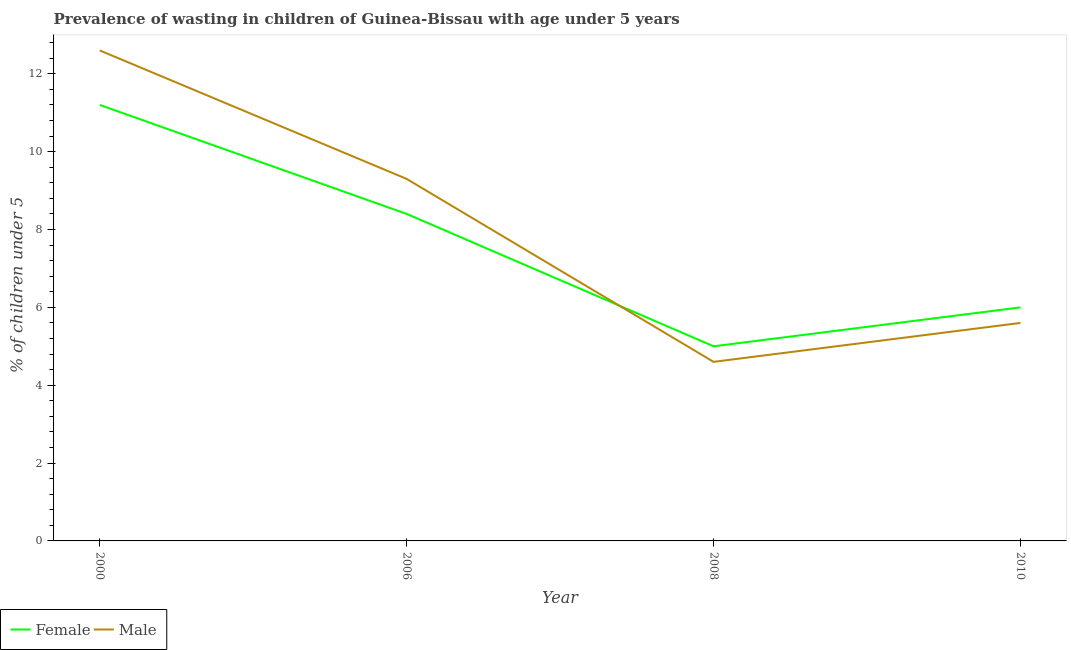How many different coloured lines are there?
Provide a short and direct response. 2. Does the line corresponding to percentage of undernourished male children intersect with the line corresponding to percentage of undernourished female children?
Your answer should be very brief. Yes. Is the number of lines equal to the number of legend labels?
Offer a terse response. Yes. What is the percentage of undernourished male children in 2010?
Make the answer very short. 5.6. Across all years, what is the maximum percentage of undernourished male children?
Make the answer very short. 12.6. Across all years, what is the minimum percentage of undernourished male children?
Provide a short and direct response. 4.6. In which year was the percentage of undernourished female children maximum?
Your response must be concise. 2000. What is the total percentage of undernourished male children in the graph?
Ensure brevity in your answer.  32.1. What is the difference between the percentage of undernourished male children in 2008 and that in 2010?
Your response must be concise. -1. What is the difference between the percentage of undernourished male children in 2006 and the percentage of undernourished female children in 2000?
Your answer should be very brief. -1.9. What is the average percentage of undernourished female children per year?
Keep it short and to the point. 7.65. In the year 2010, what is the difference between the percentage of undernourished female children and percentage of undernourished male children?
Give a very brief answer. 0.4. What is the ratio of the percentage of undernourished male children in 2006 to that in 2010?
Make the answer very short. 1.66. Is the percentage of undernourished female children in 2000 less than that in 2008?
Offer a very short reply. No. What is the difference between the highest and the second highest percentage of undernourished female children?
Ensure brevity in your answer.  2.8. What is the difference between the highest and the lowest percentage of undernourished female children?
Keep it short and to the point. 6.2. In how many years, is the percentage of undernourished female children greater than the average percentage of undernourished female children taken over all years?
Your answer should be very brief. 2. Is the sum of the percentage of undernourished female children in 2008 and 2010 greater than the maximum percentage of undernourished male children across all years?
Offer a very short reply. No. Does the percentage of undernourished male children monotonically increase over the years?
Give a very brief answer. No. Is the percentage of undernourished female children strictly greater than the percentage of undernourished male children over the years?
Offer a very short reply. No. How many years are there in the graph?
Provide a short and direct response. 4. What is the difference between two consecutive major ticks on the Y-axis?
Offer a very short reply. 2. Are the values on the major ticks of Y-axis written in scientific E-notation?
Give a very brief answer. No. Does the graph contain grids?
Your response must be concise. No. How many legend labels are there?
Offer a very short reply. 2. How are the legend labels stacked?
Your answer should be very brief. Horizontal. What is the title of the graph?
Ensure brevity in your answer.  Prevalence of wasting in children of Guinea-Bissau with age under 5 years. Does "International Tourists" appear as one of the legend labels in the graph?
Provide a short and direct response. No. What is the label or title of the X-axis?
Make the answer very short. Year. What is the label or title of the Y-axis?
Your answer should be compact.  % of children under 5. What is the  % of children under 5 in Female in 2000?
Provide a short and direct response. 11.2. What is the  % of children under 5 of Male in 2000?
Your answer should be very brief. 12.6. What is the  % of children under 5 in Female in 2006?
Offer a very short reply. 8.4. What is the  % of children under 5 in Male in 2006?
Your answer should be compact. 9.3. What is the  % of children under 5 in Male in 2008?
Provide a short and direct response. 4.6. What is the  % of children under 5 in Male in 2010?
Provide a succinct answer. 5.6. Across all years, what is the maximum  % of children under 5 of Female?
Give a very brief answer. 11.2. Across all years, what is the maximum  % of children under 5 in Male?
Offer a very short reply. 12.6. Across all years, what is the minimum  % of children under 5 in Male?
Keep it short and to the point. 4.6. What is the total  % of children under 5 of Female in the graph?
Make the answer very short. 30.6. What is the total  % of children under 5 in Male in the graph?
Ensure brevity in your answer.  32.1. What is the difference between the  % of children under 5 of Female in 2000 and that in 2006?
Offer a terse response. 2.8. What is the difference between the  % of children under 5 in Male in 2000 and that in 2006?
Offer a terse response. 3.3. What is the difference between the  % of children under 5 in Male in 2000 and that in 2008?
Make the answer very short. 8. What is the difference between the  % of children under 5 in Male in 2006 and that in 2008?
Give a very brief answer. 4.7. What is the difference between the  % of children under 5 in Female in 2006 and that in 2010?
Offer a very short reply. 2.4. What is the difference between the  % of children under 5 of Female in 2008 and that in 2010?
Your response must be concise. -1. What is the difference between the  % of children under 5 in Male in 2008 and that in 2010?
Your response must be concise. -1. What is the difference between the  % of children under 5 in Female in 2006 and the  % of children under 5 in Male in 2008?
Provide a succinct answer. 3.8. What is the difference between the  % of children under 5 in Female in 2008 and the  % of children under 5 in Male in 2010?
Make the answer very short. -0.6. What is the average  % of children under 5 of Female per year?
Give a very brief answer. 7.65. What is the average  % of children under 5 in Male per year?
Keep it short and to the point. 8.03. What is the ratio of the  % of children under 5 of Female in 2000 to that in 2006?
Your response must be concise. 1.33. What is the ratio of the  % of children under 5 in Male in 2000 to that in 2006?
Keep it short and to the point. 1.35. What is the ratio of the  % of children under 5 of Female in 2000 to that in 2008?
Provide a succinct answer. 2.24. What is the ratio of the  % of children under 5 of Male in 2000 to that in 2008?
Offer a very short reply. 2.74. What is the ratio of the  % of children under 5 in Female in 2000 to that in 2010?
Provide a short and direct response. 1.87. What is the ratio of the  % of children under 5 of Male in 2000 to that in 2010?
Your response must be concise. 2.25. What is the ratio of the  % of children under 5 in Female in 2006 to that in 2008?
Your response must be concise. 1.68. What is the ratio of the  % of children under 5 of Male in 2006 to that in 2008?
Your answer should be very brief. 2.02. What is the ratio of the  % of children under 5 in Female in 2006 to that in 2010?
Provide a short and direct response. 1.4. What is the ratio of the  % of children under 5 of Male in 2006 to that in 2010?
Offer a terse response. 1.66. What is the ratio of the  % of children under 5 of Male in 2008 to that in 2010?
Your response must be concise. 0.82. What is the difference between the highest and the second highest  % of children under 5 in Female?
Offer a terse response. 2.8. What is the difference between the highest and the second highest  % of children under 5 in Male?
Keep it short and to the point. 3.3. What is the difference between the highest and the lowest  % of children under 5 of Male?
Keep it short and to the point. 8. 